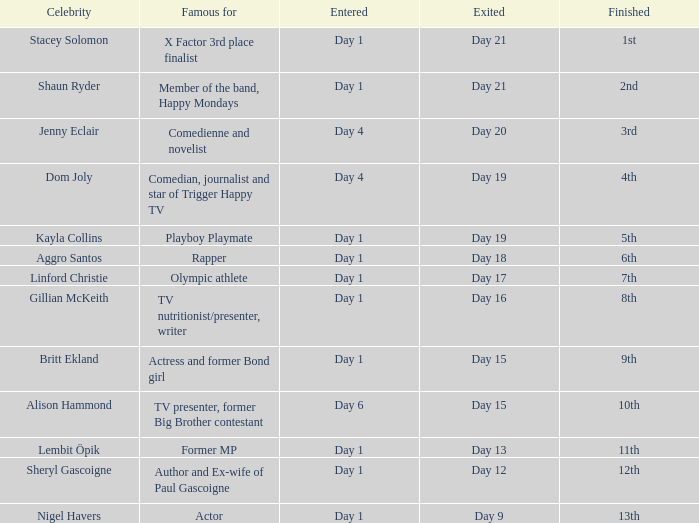What celebrity is famous for being an actor? Nigel Havers. Could you parse the entire table as a dict? {'header': ['Celebrity', 'Famous for', 'Entered', 'Exited', 'Finished'], 'rows': [['Stacey Solomon', 'X Factor 3rd place finalist', 'Day 1', 'Day 21', '1st'], ['Shaun Ryder', 'Member of the band, Happy Mondays', 'Day 1', 'Day 21', '2nd'], ['Jenny Eclair', 'Comedienne and novelist', 'Day 4', 'Day 20', '3rd'], ['Dom Joly', 'Comedian, journalist and star of Trigger Happy TV', 'Day 4', 'Day 19', '4th'], ['Kayla Collins', 'Playboy Playmate', 'Day 1', 'Day 19', '5th'], ['Aggro Santos', 'Rapper', 'Day 1', 'Day 18', '6th'], ['Linford Christie', 'Olympic athlete', 'Day 1', 'Day 17', '7th'], ['Gillian McKeith', 'TV nutritionist/presenter, writer', 'Day 1', 'Day 16', '8th'], ['Britt Ekland', 'Actress and former Bond girl', 'Day 1', 'Day 15', '9th'], ['Alison Hammond', 'TV presenter, former Big Brother contestant', 'Day 6', 'Day 15', '10th'], ['Lembit Öpik', 'Former MP', 'Day 1', 'Day 13', '11th'], ['Sheryl Gascoigne', 'Author and Ex-wife of Paul Gascoigne', 'Day 1', 'Day 12', '12th'], ['Nigel Havers', 'Actor', 'Day 1', 'Day 9', '13th']]} 